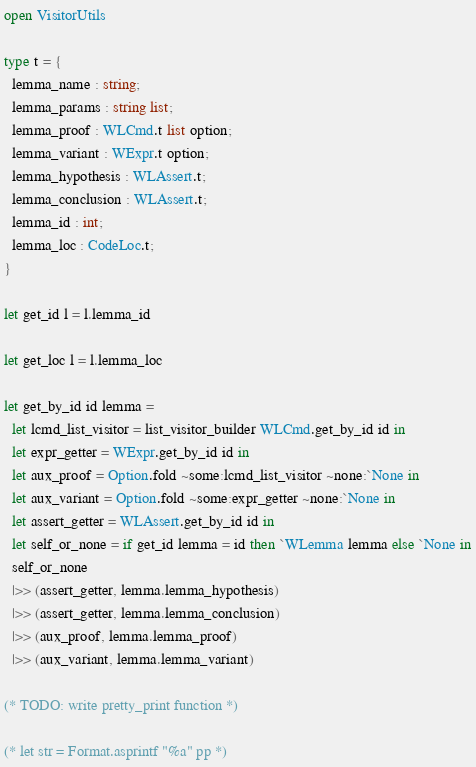<code> <loc_0><loc_0><loc_500><loc_500><_OCaml_>open VisitorUtils

type t = {
  lemma_name : string;
  lemma_params : string list;
  lemma_proof : WLCmd.t list option;
  lemma_variant : WExpr.t option;
  lemma_hypothesis : WLAssert.t;
  lemma_conclusion : WLAssert.t;
  lemma_id : int;
  lemma_loc : CodeLoc.t;
}

let get_id l = l.lemma_id

let get_loc l = l.lemma_loc

let get_by_id id lemma =
  let lcmd_list_visitor = list_visitor_builder WLCmd.get_by_id id in
  let expr_getter = WExpr.get_by_id id in
  let aux_proof = Option.fold ~some:lcmd_list_visitor ~none:`None in
  let aux_variant = Option.fold ~some:expr_getter ~none:`None in
  let assert_getter = WLAssert.get_by_id id in
  let self_or_none = if get_id lemma = id then `WLemma lemma else `None in
  self_or_none
  |>> (assert_getter, lemma.lemma_hypothesis)
  |>> (assert_getter, lemma.lemma_conclusion)
  |>> (aux_proof, lemma.lemma_proof)
  |>> (aux_variant, lemma.lemma_variant)

(* TODO: write pretty_print function *)

(* let str = Format.asprintf "%a" pp *)
</code> 